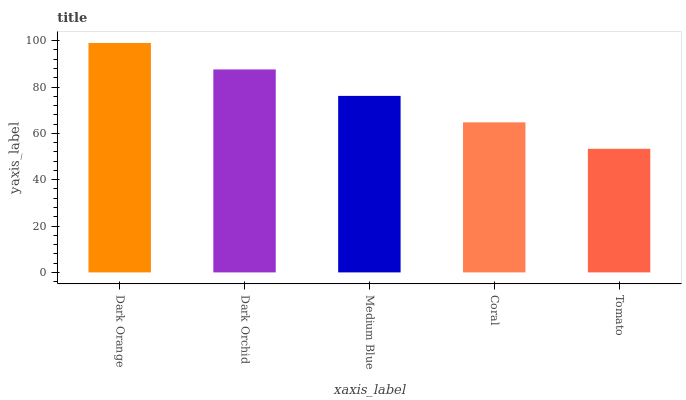Is Tomato the minimum?
Answer yes or no. Yes. Is Dark Orange the maximum?
Answer yes or no. Yes. Is Dark Orchid the minimum?
Answer yes or no. No. Is Dark Orchid the maximum?
Answer yes or no. No. Is Dark Orange greater than Dark Orchid?
Answer yes or no. Yes. Is Dark Orchid less than Dark Orange?
Answer yes or no. Yes. Is Dark Orchid greater than Dark Orange?
Answer yes or no. No. Is Dark Orange less than Dark Orchid?
Answer yes or no. No. Is Medium Blue the high median?
Answer yes or no. Yes. Is Medium Blue the low median?
Answer yes or no. Yes. Is Dark Orange the high median?
Answer yes or no. No. Is Tomato the low median?
Answer yes or no. No. 